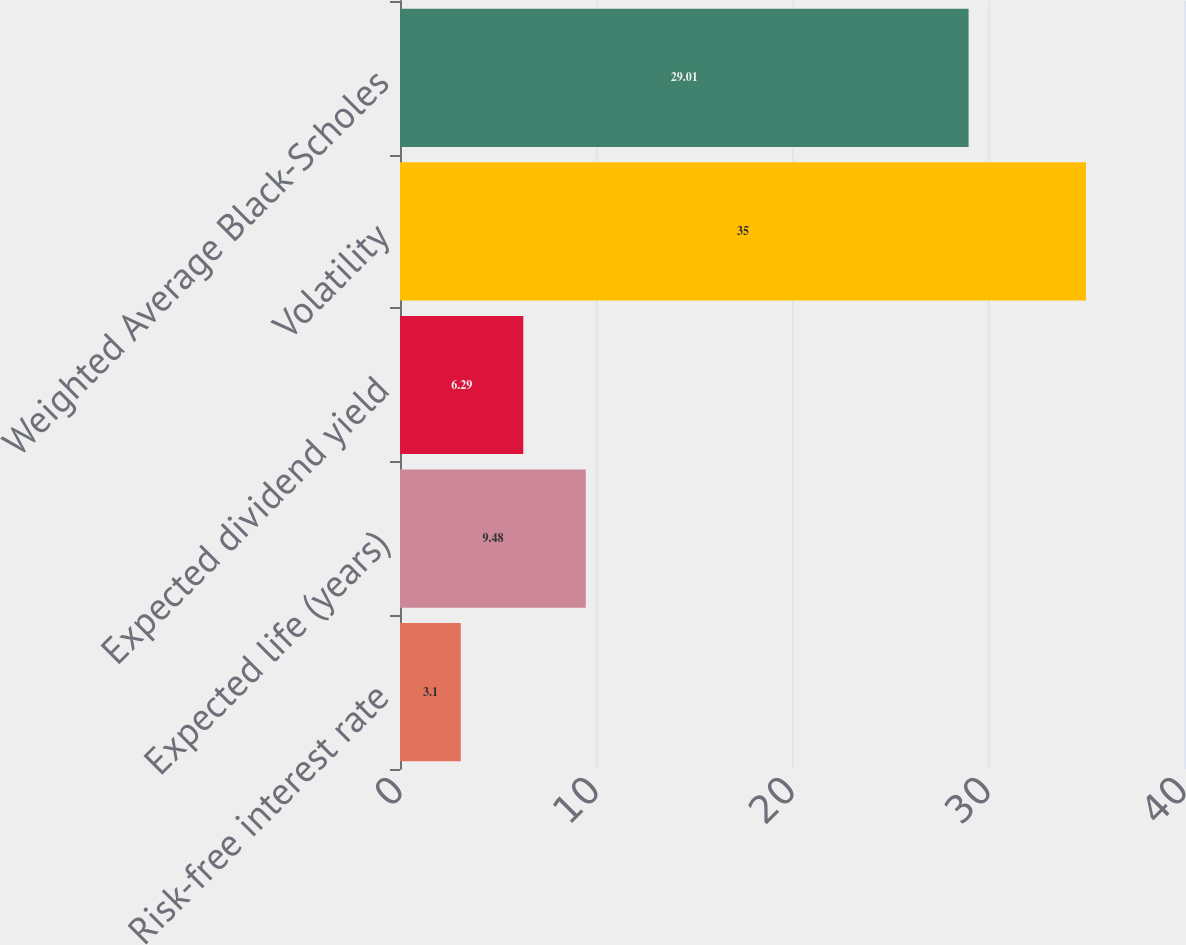<chart> <loc_0><loc_0><loc_500><loc_500><bar_chart><fcel>Risk-free interest rate<fcel>Expected life (years)<fcel>Expected dividend yield<fcel>Volatility<fcel>Weighted Average Black-Scholes<nl><fcel>3.1<fcel>9.48<fcel>6.29<fcel>35<fcel>29.01<nl></chart> 